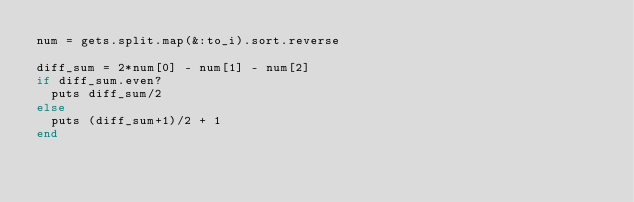<code> <loc_0><loc_0><loc_500><loc_500><_Ruby_>num = gets.split.map(&:to_i).sort.reverse

diff_sum = 2*num[0] - num[1] - num[2]
if diff_sum.even?
  puts diff_sum/2
else
  puts (diff_sum+1)/2 + 1
end</code> 